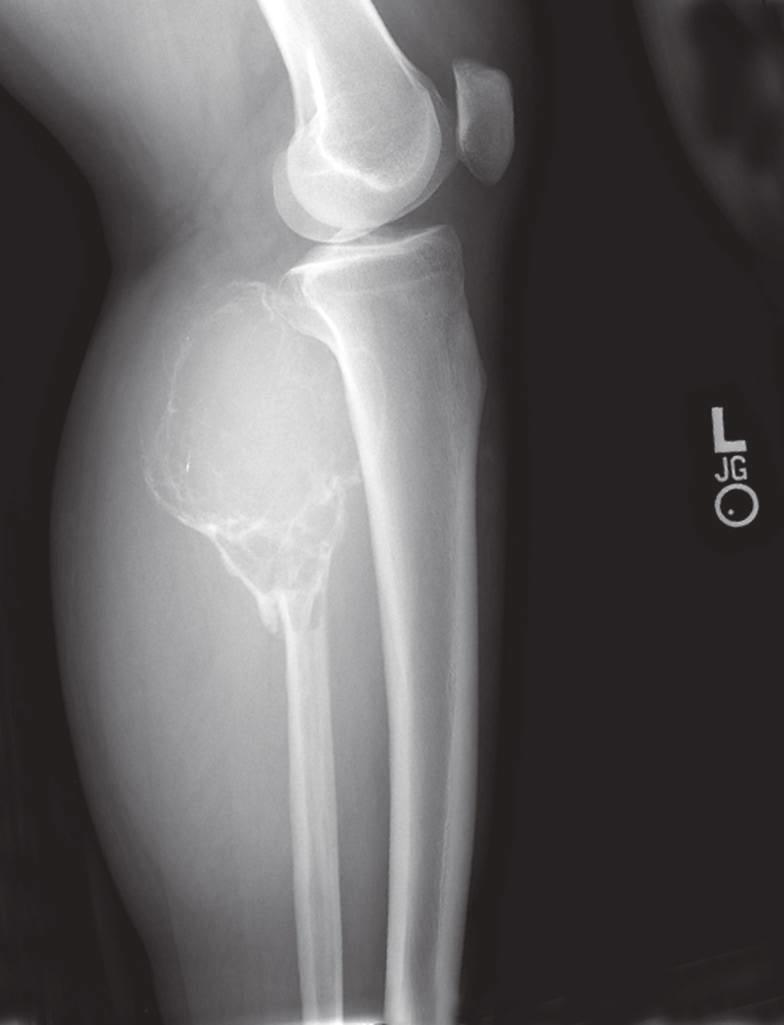what is also present?
Answer the question using a single word or phrase. A pathological fracture 